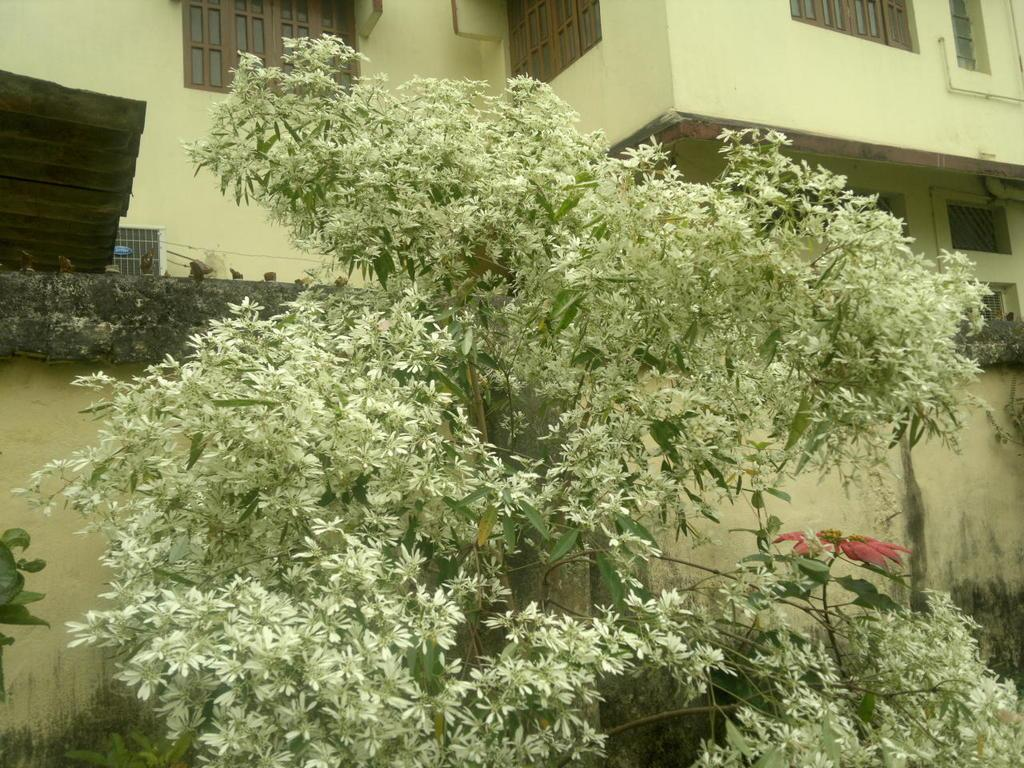What type of vegetation can be seen in the image? There are trees and plants in the image. What can be seen in the background of the image? There is a wall, a building, and other unspecified objects in the background of the image. What type of bun is being used to deliver the news in the image? There is no bun or news delivery in the image; it features trees, plants, and a background with a wall, building, and other unspecified objects. 